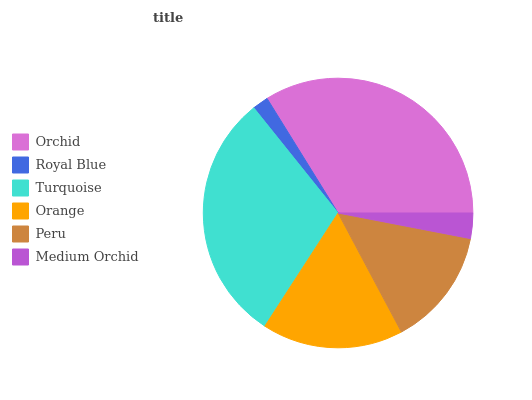Is Royal Blue the minimum?
Answer yes or no. Yes. Is Orchid the maximum?
Answer yes or no. Yes. Is Turquoise the minimum?
Answer yes or no. No. Is Turquoise the maximum?
Answer yes or no. No. Is Turquoise greater than Royal Blue?
Answer yes or no. Yes. Is Royal Blue less than Turquoise?
Answer yes or no. Yes. Is Royal Blue greater than Turquoise?
Answer yes or no. No. Is Turquoise less than Royal Blue?
Answer yes or no. No. Is Orange the high median?
Answer yes or no. Yes. Is Peru the low median?
Answer yes or no. Yes. Is Medium Orchid the high median?
Answer yes or no. No. Is Orchid the low median?
Answer yes or no. No. 